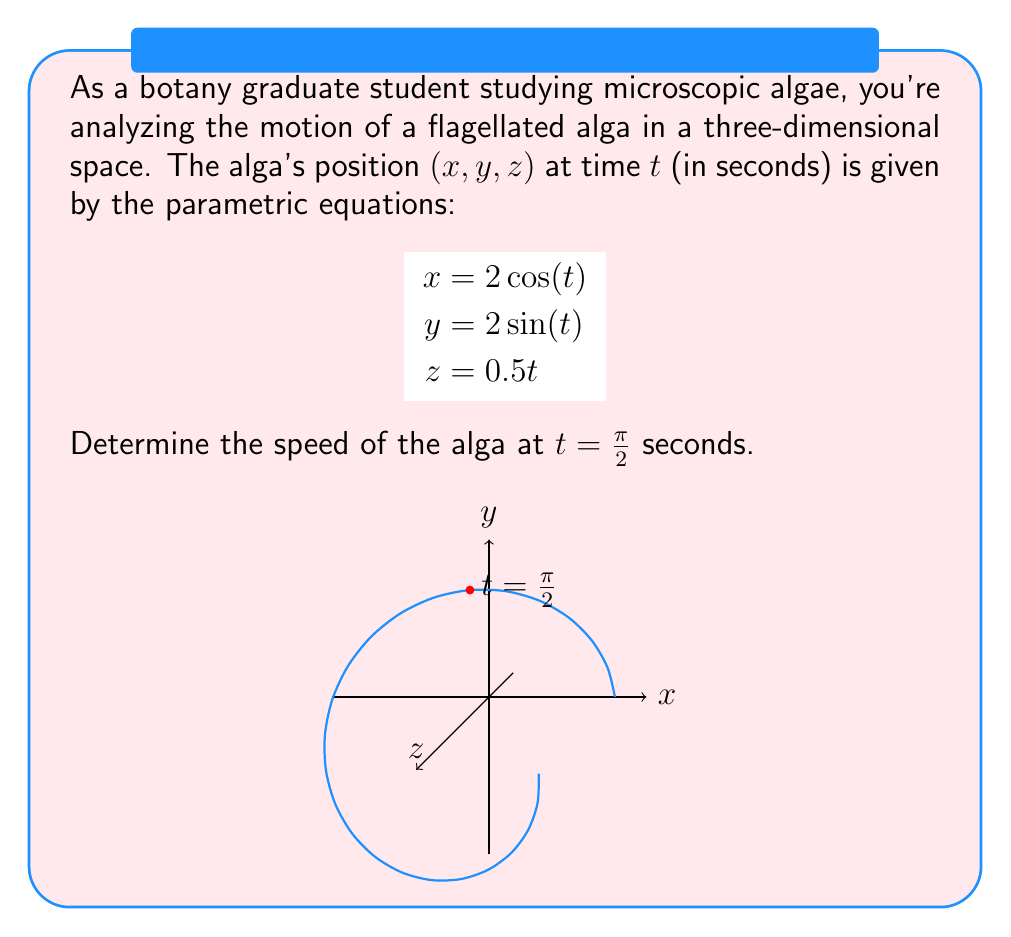Help me with this question. To find the speed of the alga, we need to calculate the magnitude of its velocity vector at $t = \frac{\pi}{2}$. Let's approach this step-by-step:

1) First, we need to find the velocity components by differentiating each parametric equation with respect to $t$:

   $$\begin{align*}
   \frac{dx}{dt} &= -2\sin(t) \\
   \frac{dy}{dt} &= 2\cos(t) \\
   \frac{dz}{dt} &= 0.5
   \end{align*}$$

2) The velocity vector at any time $t$ is:

   $$\vec{v}(t) = \left(-2\sin(t), 2\cos(t), 0.5\right)$$

3) At $t = \frac{\pi}{2}$, we have:

   $$\vec{v}\left(\frac{\pi}{2}\right) = \left(-2\sin\left(\frac{\pi}{2}\right), 2\cos\left(\frac{\pi}{2}\right), 0.5\right) = (-2, 0, 0.5)$$

4) The speed is the magnitude of the velocity vector. We can calculate this using the Pythagorean theorem in three dimensions:

   $$\text{speed} = \sqrt{\left(\frac{dx}{dt}\right)^2 + \left(\frac{dy}{dt}\right)^2 + \left(\frac{dz}{dt}\right)^2}$$

5) Substituting our values:

   $$\text{speed} = \sqrt{(-2)^2 + 0^2 + 0.5^2} = \sqrt{4 + 0.25} = \sqrt{4.25}$$

6) Simplifying:

   $$\text{speed} = \frac{\sqrt{17}}{2} \approx 2.06$$

Therefore, the speed of the alga at $t = \frac{\pi}{2}$ seconds is $\frac{\sqrt{17}}{2}$ units per second.
Answer: $\frac{\sqrt{17}}{2}$ units/second 